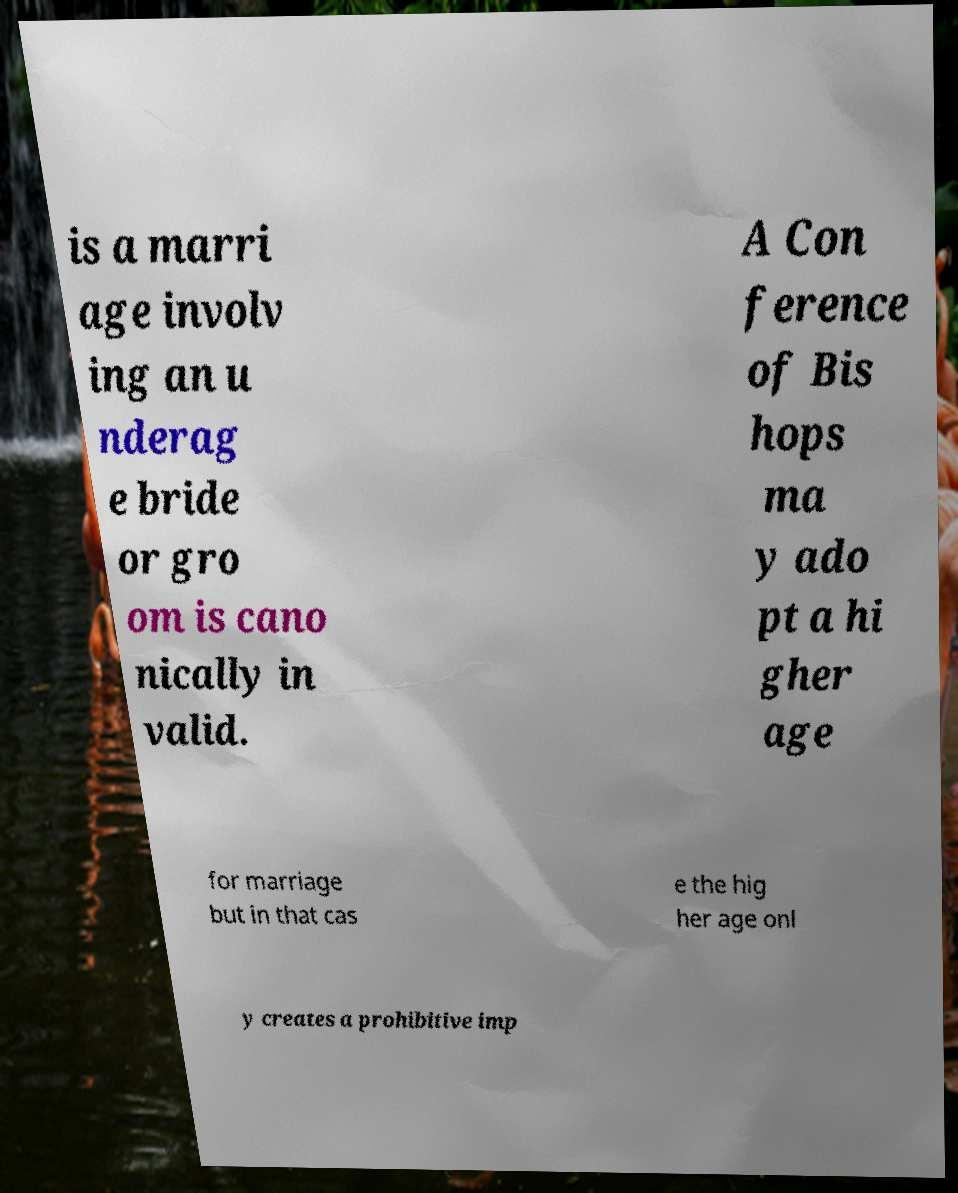Please read and relay the text visible in this image. What does it say? is a marri age involv ing an u nderag e bride or gro om is cano nically in valid. A Con ference of Bis hops ma y ado pt a hi gher age for marriage but in that cas e the hig her age onl y creates a prohibitive imp 